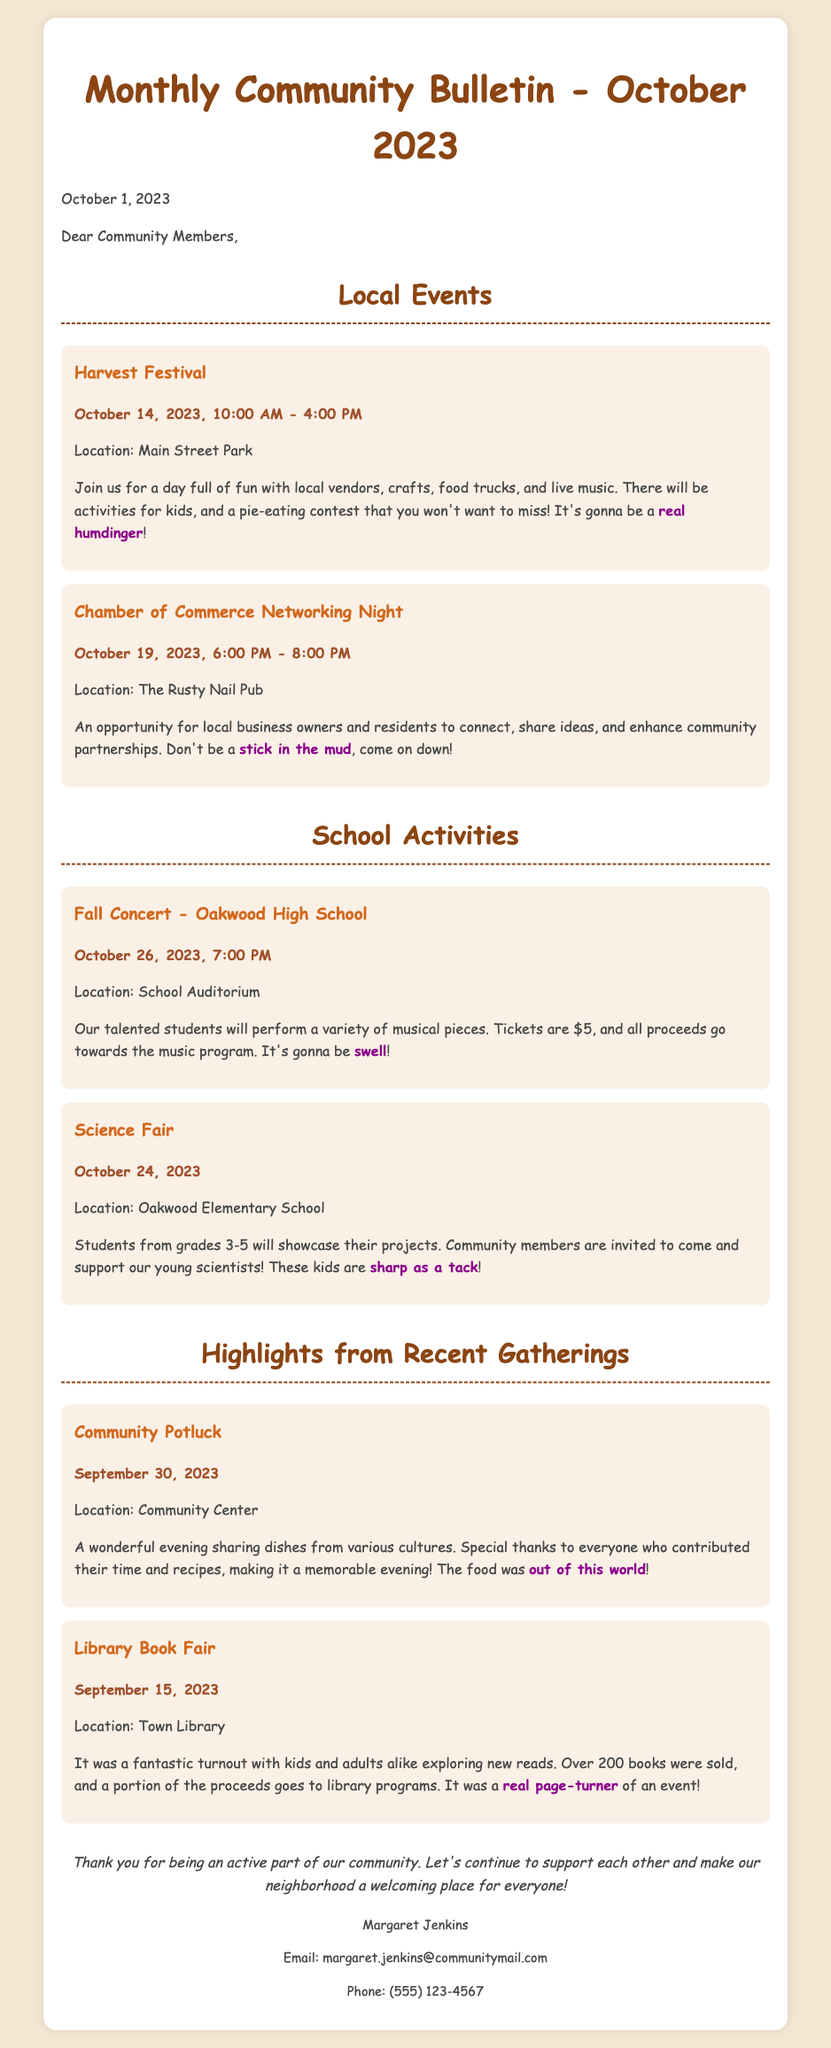what is the date of the Harvest Festival? The date is specifically mentioned in the Local Events section under the Harvest Festival heading.
Answer: October 14, 2023 where is the Chamber of Commerce Networking Night held? The location is provided in the details of the Networking Night event.
Answer: The Rusty Nail Pub how much are tickets for the Fall Concert? The ticket price is specified in the School Activities section for the Fall Concert.
Answer: $5 which school is hosting the Science Fair? The document indicates which school is responsible for the Science Fair in the School Activities section.
Answer: Oakwood Elementary School what was a highlight from the Community Potluck? This information is noted in the Highlights section and refers to the community gathering mentioned.
Answer: sharing dishes from various cultures what is the total number of books sold at the Library Book Fair? The document mentions the number of books sold at the Library Book Fair, which helps evaluate the event's success.
Answer: Over 200 books what type of vendors will be present at the Harvest Festival? The description of the Harvest Festival in the Local Events section outlines the types of vendors attending.
Answer: local vendors how should residents feel encouraged to participate in community events? The closing paragraph reflects the overall sentiment and encouragement towards community involvement.
Answer: active part of our community 